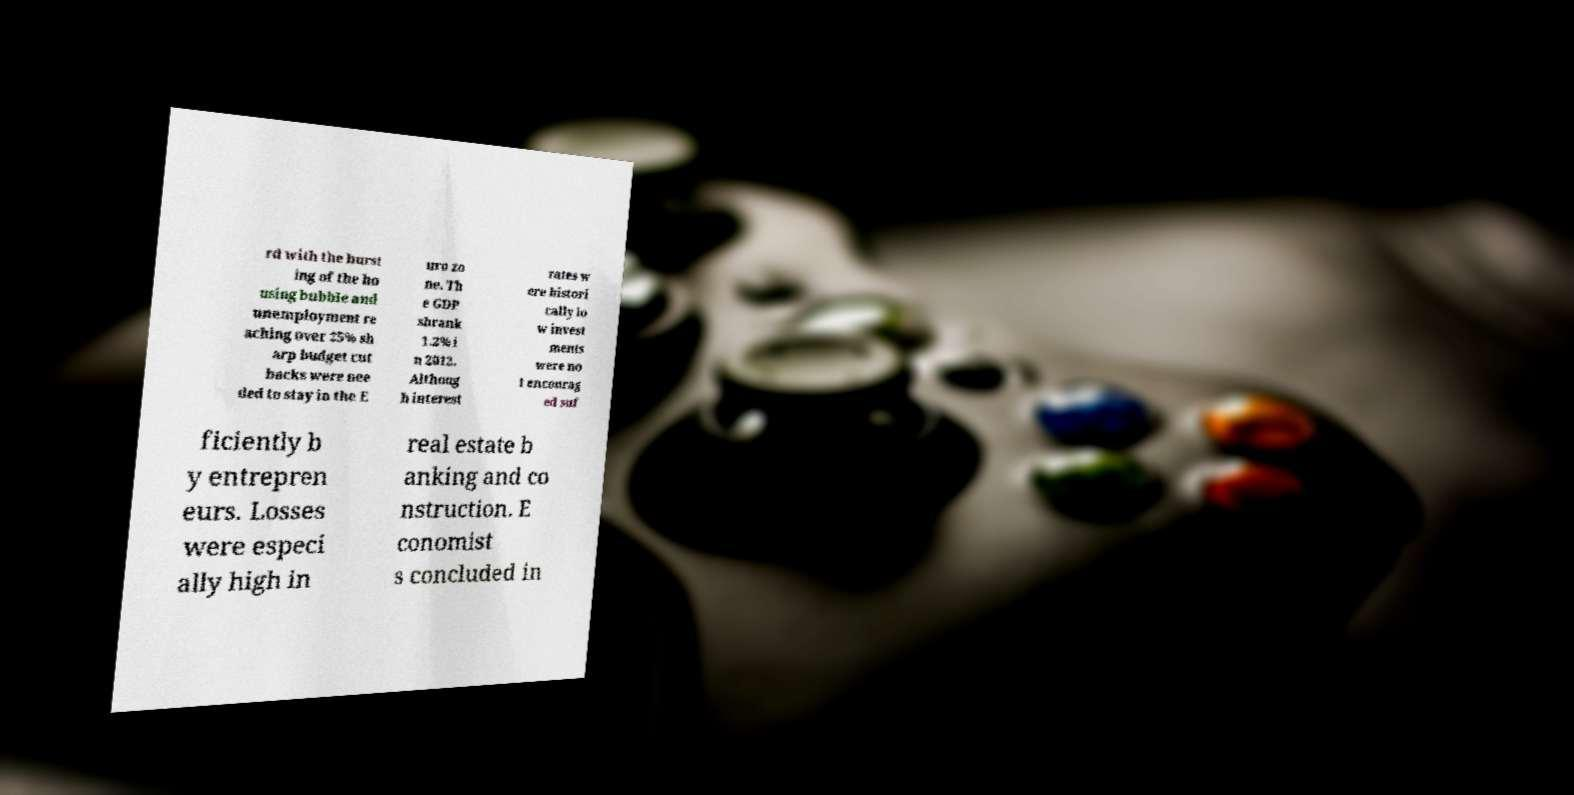Could you extract and type out the text from this image? rd with the burst ing of the ho using bubble and unemployment re aching over 25% sh arp budget cut backs were nee ded to stay in the E uro zo ne. Th e GDP shrank 1.2% i n 2012. Althoug h interest rates w ere histori cally lo w invest ments were no t encourag ed suf ficiently b y entrepren eurs. Losses were especi ally high in real estate b anking and co nstruction. E conomist s concluded in 